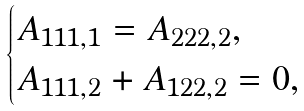<formula> <loc_0><loc_0><loc_500><loc_500>\begin{cases} A _ { 1 1 1 , 1 } = A _ { 2 2 2 , 2 } , \\ A _ { 1 1 1 , 2 } + A _ { 1 2 2 , 2 } = 0 , \end{cases}</formula> 